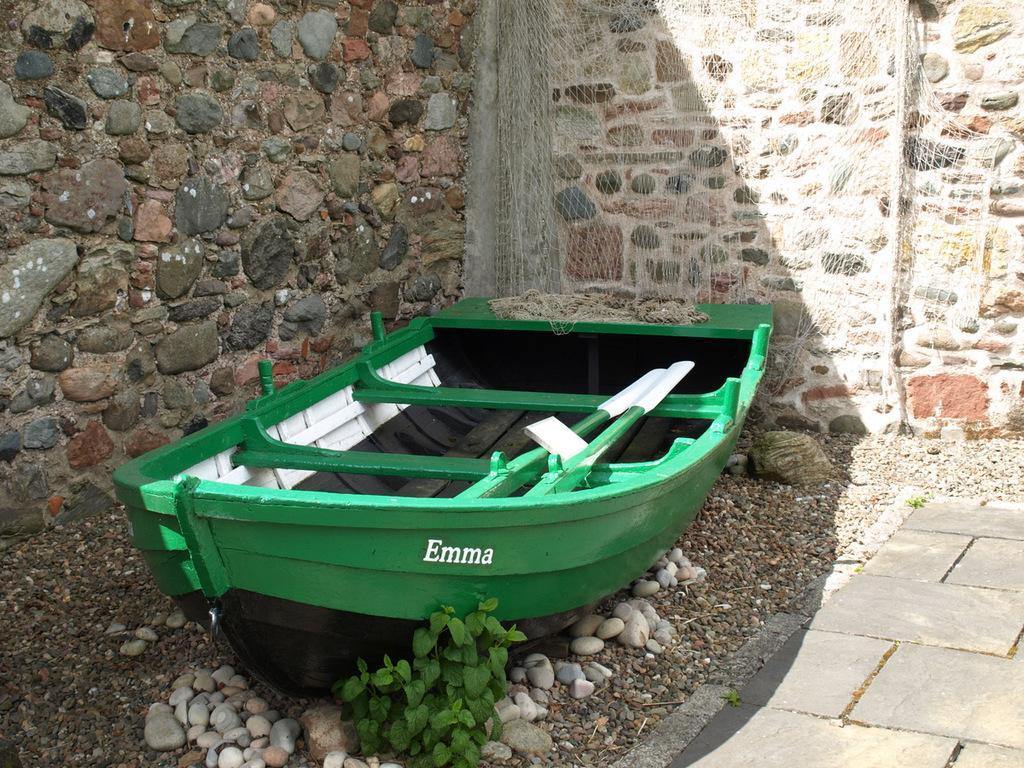Please provide a concise description of this image. In this picture, there is a boat which is in green in color. At the bottom, there are stones and tiles. On the top, there is a wall and a net. 